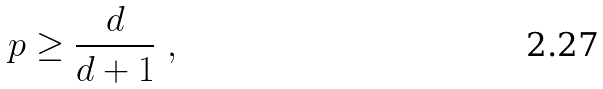Convert formula to latex. <formula><loc_0><loc_0><loc_500><loc_500>p \geq \frac { d } { d + 1 } \ ,</formula> 